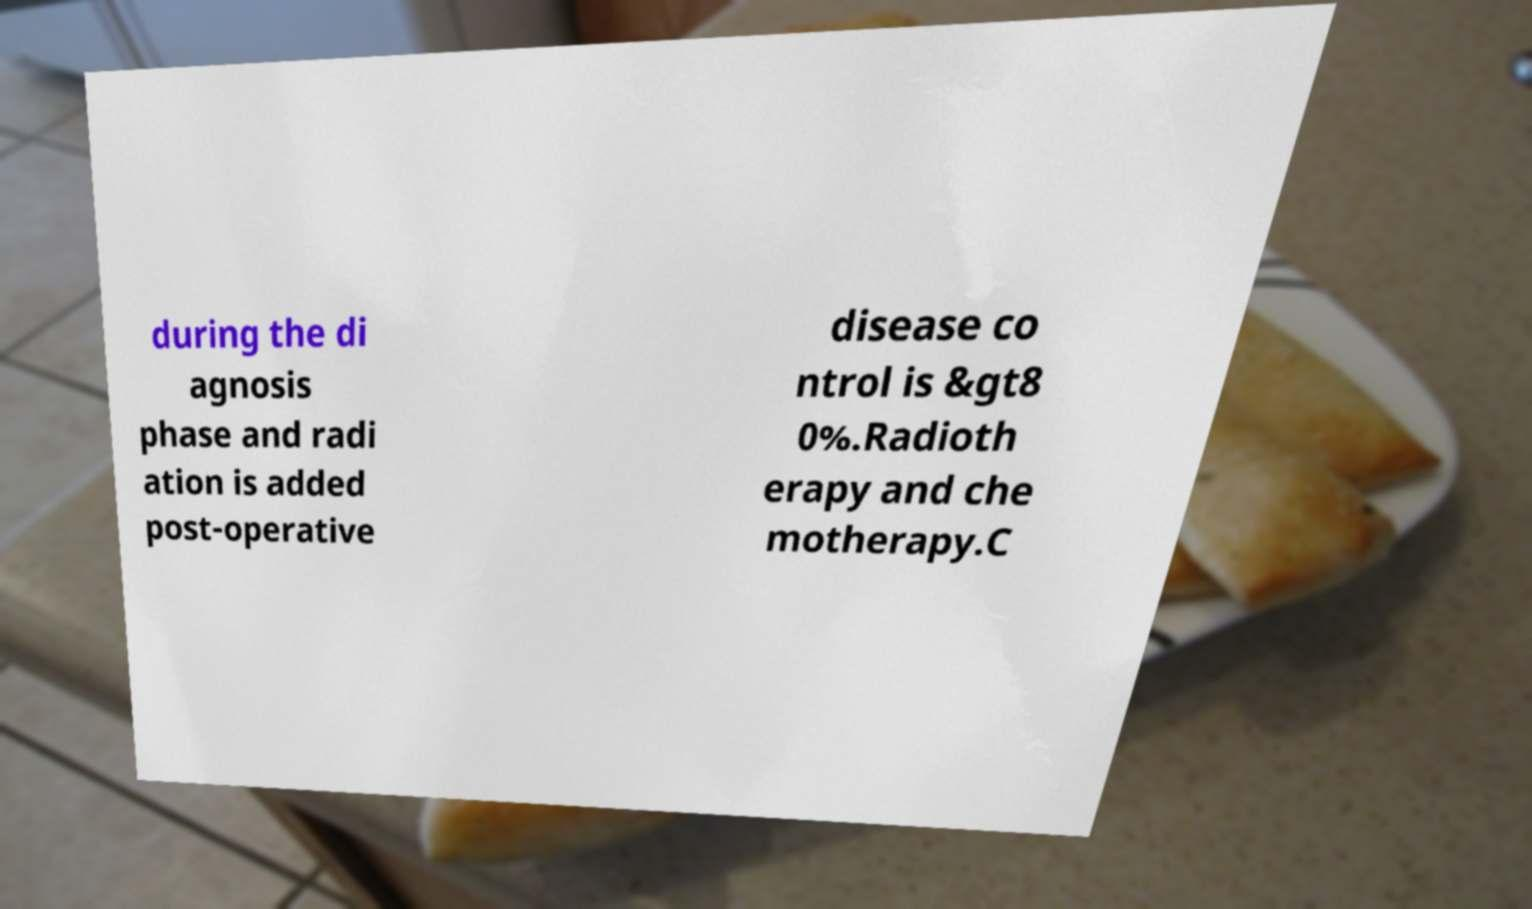I need the written content from this picture converted into text. Can you do that? during the di agnosis phase and radi ation is added post-operative disease co ntrol is &gt8 0%.Radioth erapy and che motherapy.C 